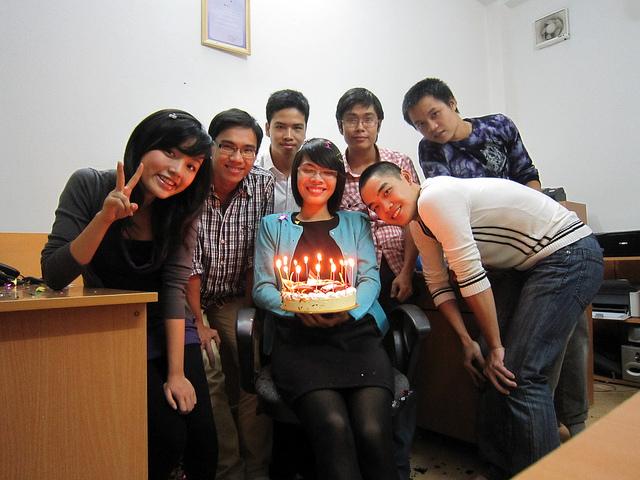How many ladies are wearing white tops?
Short answer required. 0. Are these men fashionistas?
Be succinct. No. What are these two men looking at?
Give a very brief answer. Camera. What sign is the woman saying?
Keep it brief. Peace. How many people are in the picture?
Write a very short answer. 7. Why is the man smiling?
Short answer required. Party. How many people are smiling in this picture?
Quick response, please. 4. What does the cake represent?
Keep it brief. Birthday. How many people are there?
Be succinct. 7. What are they wearing?
Concise answer only. Clothes. How many people are looking at the camera?
Be succinct. 7. How many candles are there?
Quick response, please. 13. Is this a large room?
Answer briefly. No. Whose birthday is it?
Answer briefly. Woman. How many people in the background are wearing pants?
Quick response, please. 6. 